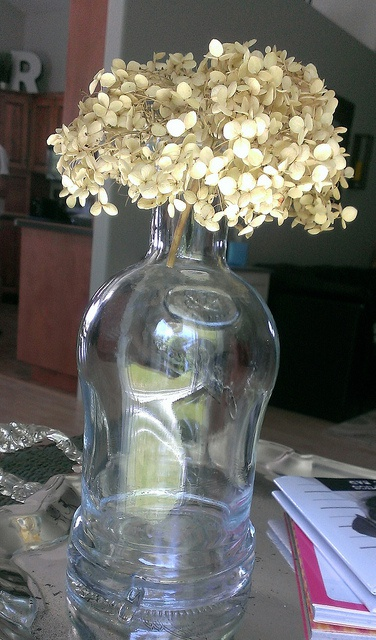Describe the objects in this image and their specific colors. I can see bottle in black, gray, darkgray, and lightgray tones, vase in black, gray, and darkgray tones, book in black, darkgray, and lavender tones, book in black, lavender, and purple tones, and book in black, darkgray, lavender, and gray tones in this image. 